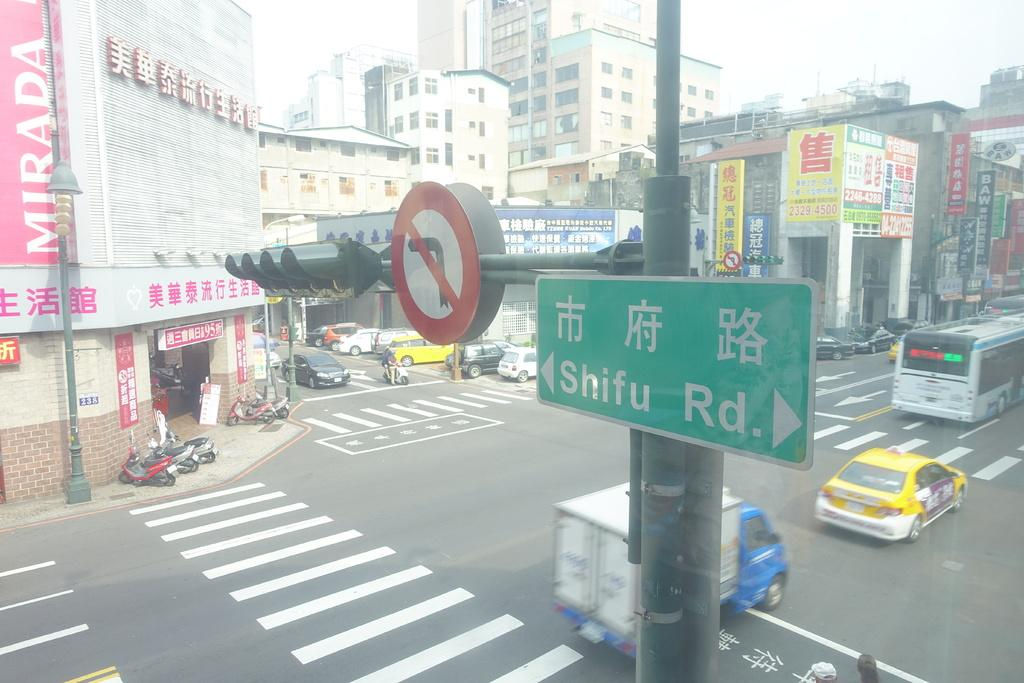<image>
Summarize the visual content of the image. A busy street there is a sign that says Mirada and Shifu Road. 